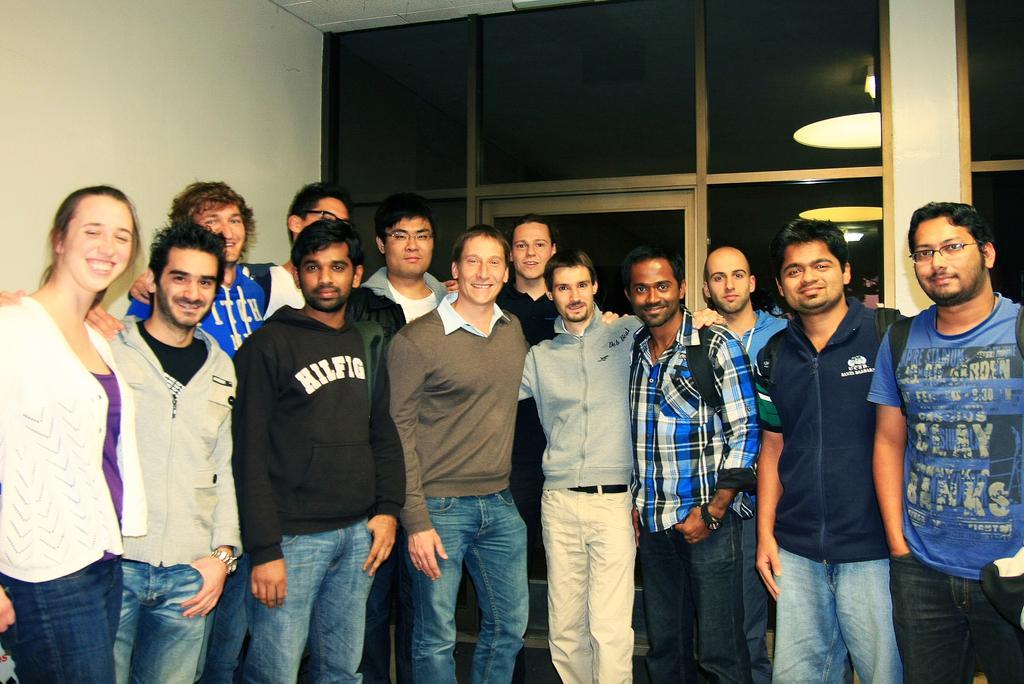Can you describe this image briefly? In this picture we can observe some people standing. There are men and a woman. All of them were smiling. On the left side there is a wall. In the background there is a glass door. 